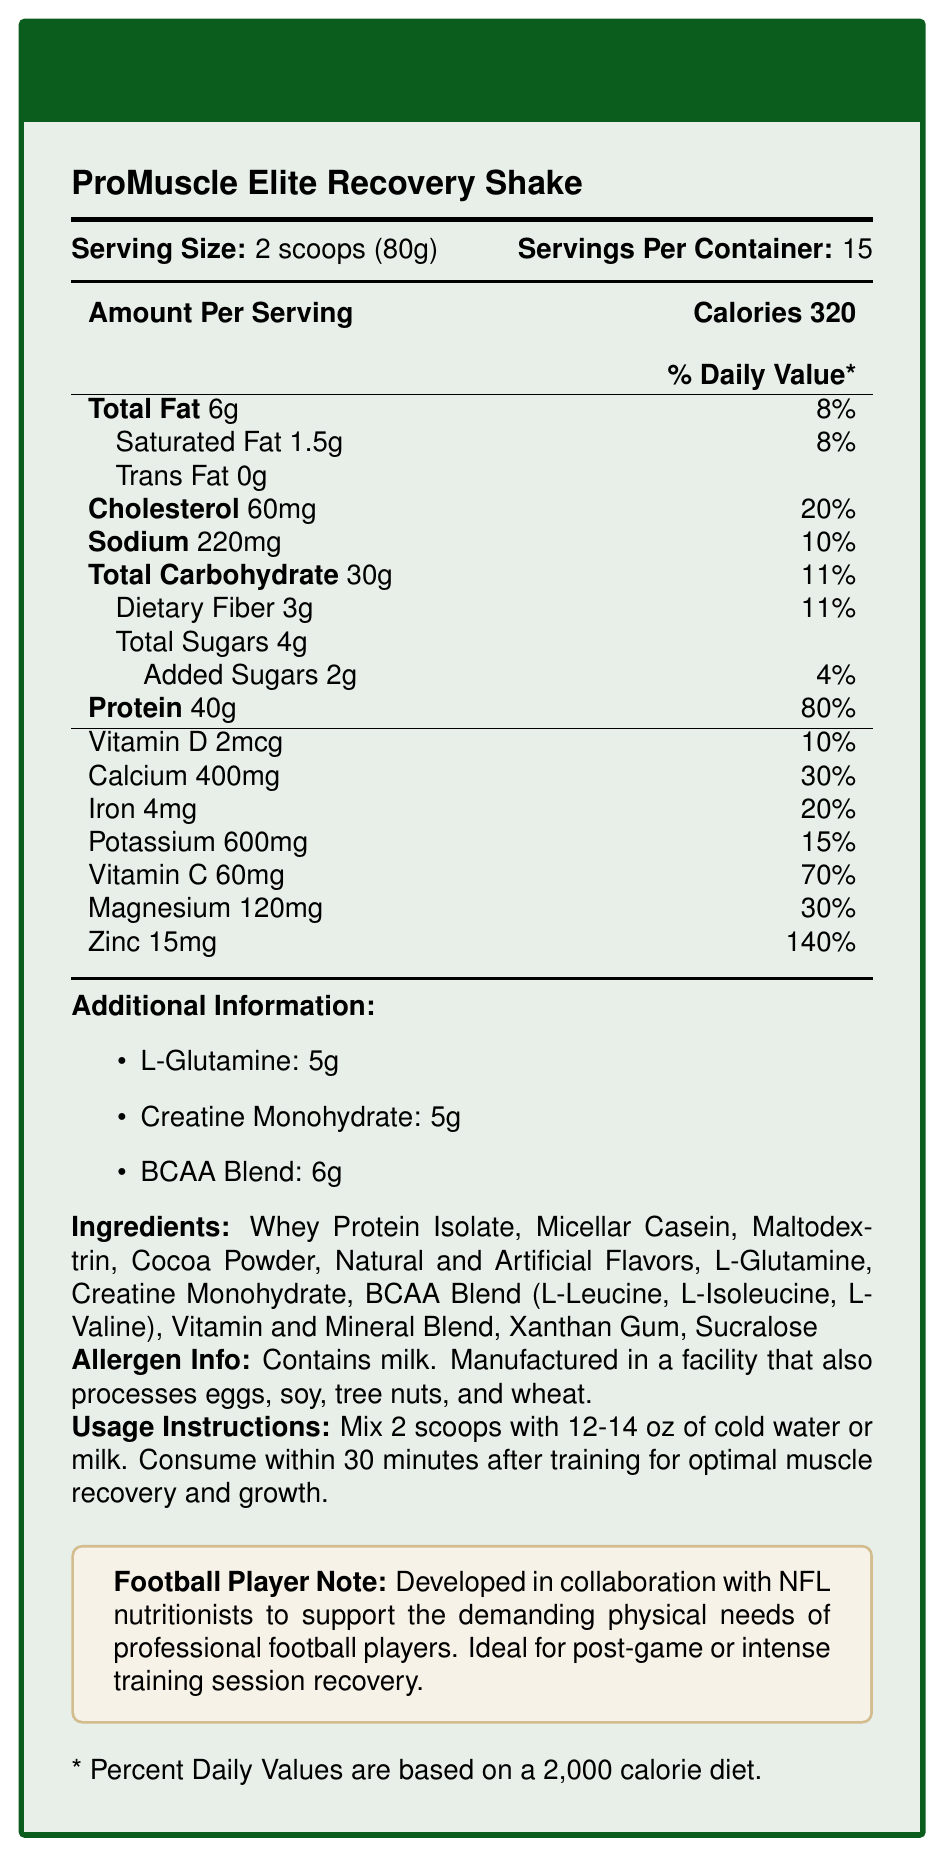what is the serving size of the ProMuscle Elite Recovery Shake? The serving size is listed as "2 scoops (80g)" under the "Serving Size" section.
Answer: 2 scoops (80g) how many calories are in one serving? One serving contains 320 calories, as shown in the "Calories" section.
Answer: 320 how many grams of protein are in a serving? One serving contains 40 grams of protein, as indicated in the "Protein" section.
Answer: 40g what is the daily value percentage of calcium per serving? The daily value for calcium is 30%, as listed in the "Calcium" section under "Vitamin and Mineral Blend".
Answer: 30% how much L-Glutamine is in one serving? One serving contains 5 grams of L-Glutamine, found in the "Additional Information" section.
Answer: 5g which ingredient is not listed in the document? 
A. Whey Protein Isolate 
B. L-Arginine 
C. Maltodextrin 
D. Sucralose L-Arginine is not listed among the ingredients; the listed ingredients include Whey Protein Isolate, Maltodextrin, and Sucralose among others.
Answer: B what is the main purpose of the product according to the document? 
A. Weight Loss 
B. Muscle gain and recovery 
C. Increasing endurance 
D. Improving sleep The product is formulated for muscle gain and recovery, as indicated in the product description and the "Football Player Note".
Answer: B does the ProMuscle Elite Recovery Shake contain any trans fat? The document lists "Trans Fat" as 0g, indicating there is no trans fat in the product.
Answer: No is the product suitable for someone with a milk allergy? The allergen information states that it contains milk and is manufactured in a facility that processes other allergens.
Answer: No summarize the key information provided in the document. The document provides detailed nutritional information, serving size, and instructions, targeting athletes for muscle recovery.
Answer: The ProMuscle Elite Recovery Shake is formulated for muscle gain and recovery, ideal for post-game or intense training session recovery for football players. Each serving size of 2 scoops (80g) provides 320 calories, 40g of protein, and has various vitamins and minerals. It includes ingredients like Whey Protein Isolate and BCAA Blend and contains milk. The shake should be mixed with water or milk and consumed within 30 minutes after training for optimal results. how many servings are there per container? Each container has 15 servings, as indicated under "Servings Per Container".
Answer: 15 what vitamin has the highest daily value percentage? 
A. Vitamin D 
B. Vitamin C 
C. Iron 
D. Magnesium Vitamin C has the highest daily value percentage at 70%, as listed in the "Vitamin and Mineral Blend" section.
Answer: B how much potassium is in one serving? There is 600mg of potassium in one serving, as indicated under the "Potassium" section.
Answer: 600mg what should you mix with the shake for best results? The usage instructions specify mixing with 12-14 oz of cold water or milk for optimal results.
Answer: Cold water or milk how much cholesterol is in one serving, and what percentage of the daily value does this represent? One serving has 60mg of cholesterol, representing 20% of the daily value, as shown in the "Cholesterol" section.
Answer: 60mg, 20% which combination of ingredients are included in the product for muscle recovery? These ingredients (Whey Protein Isolate, Creatine Monohydrate, BCAA Blend) are specifically mentioned for muscle gain and recovery.
Answer: Whey Protein Isolate, Creatine Monohydrate, BCAA Blend what percentage of daily fiber does one serving offer? One serving provides 11% of the daily fiber requirement, as indicated in the "Dietary Fiber" section.
Answer: 11% what is the daily value percentage for iron in a serving? The daily value percentage for iron is 20%, as listed in the "Iron" section.
Answer: 20% does the product contain added sugars? The document shows "Added Sugars" at 2g, representing 4% of the daily value.
Answer: Yes is the product developed in collaboration with NFL nutritionists? This is indicated in the "Football Player Note" stating its collaboration with NFL nutritionists.
Answer: Yes what is the total carbohydrate content in one serving? The total carbohydrate content in one serving is listed as 30g in the "Total Carbohydrate" section.
Answer: 30g does the product have any natural flavors? The ingredient list includes "Natural and Artificial Flavors."
Answer: Yes 